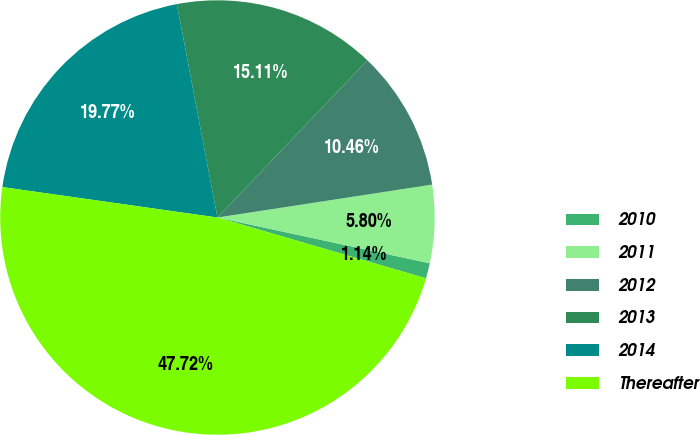Convert chart. <chart><loc_0><loc_0><loc_500><loc_500><pie_chart><fcel>2010<fcel>2011<fcel>2012<fcel>2013<fcel>2014<fcel>Thereafter<nl><fcel>1.14%<fcel>5.8%<fcel>10.46%<fcel>15.11%<fcel>19.77%<fcel>47.72%<nl></chart> 